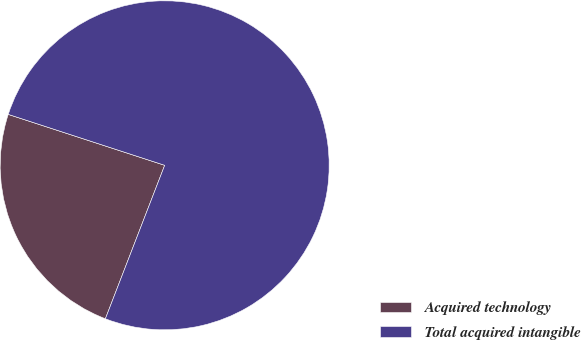Convert chart to OTSL. <chart><loc_0><loc_0><loc_500><loc_500><pie_chart><fcel>Acquired technology<fcel>Total acquired intangible<nl><fcel>24.14%<fcel>75.86%<nl></chart> 